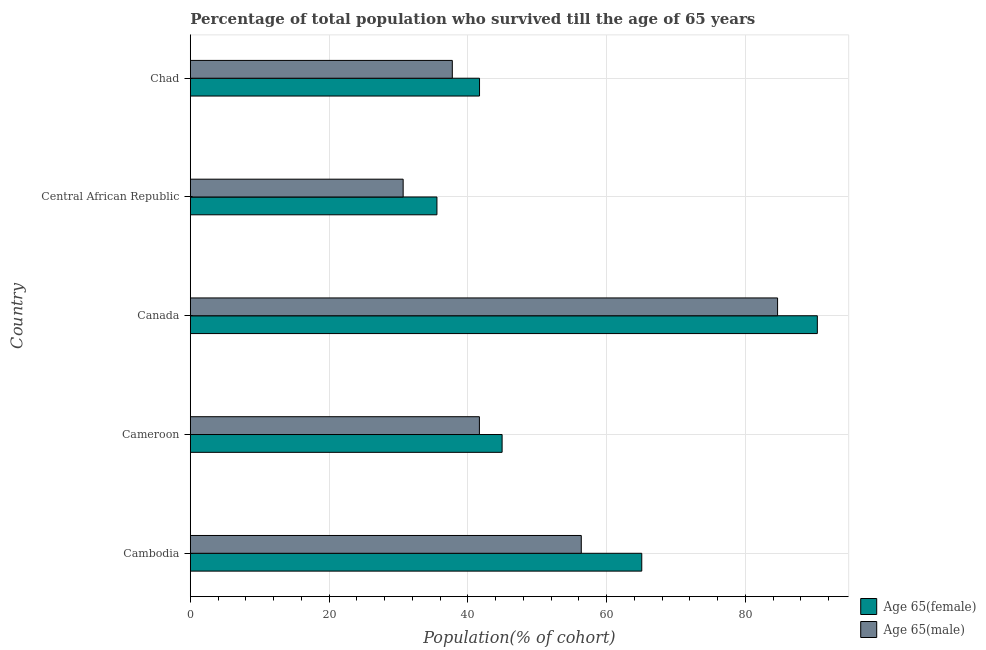How many groups of bars are there?
Offer a terse response. 5. Are the number of bars per tick equal to the number of legend labels?
Your answer should be compact. Yes. How many bars are there on the 3rd tick from the bottom?
Your answer should be very brief. 2. What is the label of the 5th group of bars from the top?
Provide a succinct answer. Cambodia. What is the percentage of female population who survived till age of 65 in Central African Republic?
Offer a terse response. 35.54. Across all countries, what is the maximum percentage of male population who survived till age of 65?
Provide a succinct answer. 84.63. Across all countries, what is the minimum percentage of female population who survived till age of 65?
Give a very brief answer. 35.54. In which country was the percentage of female population who survived till age of 65 minimum?
Give a very brief answer. Central African Republic. What is the total percentage of male population who survived till age of 65 in the graph?
Offer a terse response. 251.06. What is the difference between the percentage of female population who survived till age of 65 in Cameroon and that in Central African Republic?
Offer a very short reply. 9.39. What is the difference between the percentage of male population who survived till age of 65 in Central African Republic and the percentage of female population who survived till age of 65 in Cambodia?
Offer a very short reply. -34.38. What is the average percentage of female population who survived till age of 65 per country?
Ensure brevity in your answer.  55.51. What is the difference between the percentage of female population who survived till age of 65 and percentage of male population who survived till age of 65 in Chad?
Offer a very short reply. 3.92. What is the ratio of the percentage of female population who survived till age of 65 in Canada to that in Chad?
Offer a terse response. 2.17. Is the percentage of male population who survived till age of 65 in Cambodia less than that in Canada?
Your answer should be compact. Yes. What is the difference between the highest and the second highest percentage of female population who survived till age of 65?
Keep it short and to the point. 25.3. What is the difference between the highest and the lowest percentage of male population who survived till age of 65?
Give a very brief answer. 53.95. Is the sum of the percentage of male population who survived till age of 65 in Cambodia and Central African Republic greater than the maximum percentage of female population who survived till age of 65 across all countries?
Ensure brevity in your answer.  No. What does the 1st bar from the top in Cambodia represents?
Give a very brief answer. Age 65(male). What does the 1st bar from the bottom in Chad represents?
Keep it short and to the point. Age 65(female). How many bars are there?
Provide a succinct answer. 10. Are the values on the major ticks of X-axis written in scientific E-notation?
Your answer should be very brief. No. Does the graph contain any zero values?
Offer a very short reply. No. Where does the legend appear in the graph?
Give a very brief answer. Bottom right. What is the title of the graph?
Your answer should be compact. Percentage of total population who survived till the age of 65 years. Does "Old" appear as one of the legend labels in the graph?
Keep it short and to the point. No. What is the label or title of the X-axis?
Offer a very short reply. Population(% of cohort). What is the label or title of the Y-axis?
Give a very brief answer. Country. What is the Population(% of cohort) of Age 65(female) in Cambodia?
Offer a very short reply. 65.06. What is the Population(% of cohort) of Age 65(male) in Cambodia?
Your response must be concise. 56.34. What is the Population(% of cohort) in Age 65(female) in Cameroon?
Offer a very short reply. 44.93. What is the Population(% of cohort) in Age 65(male) in Cameroon?
Keep it short and to the point. 41.66. What is the Population(% of cohort) of Age 65(female) in Canada?
Provide a succinct answer. 90.36. What is the Population(% of cohort) in Age 65(male) in Canada?
Your answer should be very brief. 84.63. What is the Population(% of cohort) in Age 65(female) in Central African Republic?
Provide a succinct answer. 35.54. What is the Population(% of cohort) of Age 65(male) in Central African Republic?
Your answer should be compact. 30.67. What is the Population(% of cohort) of Age 65(female) in Chad?
Offer a very short reply. 41.68. What is the Population(% of cohort) of Age 65(male) in Chad?
Make the answer very short. 37.76. Across all countries, what is the maximum Population(% of cohort) of Age 65(female)?
Your answer should be very brief. 90.36. Across all countries, what is the maximum Population(% of cohort) in Age 65(male)?
Offer a very short reply. 84.63. Across all countries, what is the minimum Population(% of cohort) of Age 65(female)?
Offer a very short reply. 35.54. Across all countries, what is the minimum Population(% of cohort) in Age 65(male)?
Provide a short and direct response. 30.67. What is the total Population(% of cohort) in Age 65(female) in the graph?
Your answer should be very brief. 277.57. What is the total Population(% of cohort) in Age 65(male) in the graph?
Ensure brevity in your answer.  251.06. What is the difference between the Population(% of cohort) of Age 65(female) in Cambodia and that in Cameroon?
Ensure brevity in your answer.  20.12. What is the difference between the Population(% of cohort) of Age 65(male) in Cambodia and that in Cameroon?
Give a very brief answer. 14.68. What is the difference between the Population(% of cohort) in Age 65(female) in Cambodia and that in Canada?
Provide a short and direct response. -25.3. What is the difference between the Population(% of cohort) of Age 65(male) in Cambodia and that in Canada?
Offer a very short reply. -28.29. What is the difference between the Population(% of cohort) in Age 65(female) in Cambodia and that in Central African Republic?
Make the answer very short. 29.51. What is the difference between the Population(% of cohort) in Age 65(male) in Cambodia and that in Central African Republic?
Give a very brief answer. 25.67. What is the difference between the Population(% of cohort) in Age 65(female) in Cambodia and that in Chad?
Offer a very short reply. 23.38. What is the difference between the Population(% of cohort) in Age 65(male) in Cambodia and that in Chad?
Offer a terse response. 18.58. What is the difference between the Population(% of cohort) in Age 65(female) in Cameroon and that in Canada?
Give a very brief answer. -45.42. What is the difference between the Population(% of cohort) of Age 65(male) in Cameroon and that in Canada?
Your response must be concise. -42.97. What is the difference between the Population(% of cohort) of Age 65(female) in Cameroon and that in Central African Republic?
Keep it short and to the point. 9.39. What is the difference between the Population(% of cohort) of Age 65(male) in Cameroon and that in Central African Republic?
Provide a short and direct response. 10.99. What is the difference between the Population(% of cohort) in Age 65(female) in Cameroon and that in Chad?
Provide a succinct answer. 3.26. What is the difference between the Population(% of cohort) of Age 65(male) in Cameroon and that in Chad?
Offer a very short reply. 3.9. What is the difference between the Population(% of cohort) of Age 65(female) in Canada and that in Central African Republic?
Give a very brief answer. 54.82. What is the difference between the Population(% of cohort) of Age 65(male) in Canada and that in Central African Republic?
Provide a short and direct response. 53.95. What is the difference between the Population(% of cohort) of Age 65(female) in Canada and that in Chad?
Make the answer very short. 48.68. What is the difference between the Population(% of cohort) in Age 65(male) in Canada and that in Chad?
Your response must be concise. 46.87. What is the difference between the Population(% of cohort) of Age 65(female) in Central African Republic and that in Chad?
Your answer should be very brief. -6.14. What is the difference between the Population(% of cohort) in Age 65(male) in Central African Republic and that in Chad?
Make the answer very short. -7.08. What is the difference between the Population(% of cohort) in Age 65(female) in Cambodia and the Population(% of cohort) in Age 65(male) in Cameroon?
Offer a very short reply. 23.4. What is the difference between the Population(% of cohort) of Age 65(female) in Cambodia and the Population(% of cohort) of Age 65(male) in Canada?
Your answer should be very brief. -19.57. What is the difference between the Population(% of cohort) in Age 65(female) in Cambodia and the Population(% of cohort) in Age 65(male) in Central African Republic?
Make the answer very short. 34.38. What is the difference between the Population(% of cohort) in Age 65(female) in Cambodia and the Population(% of cohort) in Age 65(male) in Chad?
Make the answer very short. 27.3. What is the difference between the Population(% of cohort) in Age 65(female) in Cameroon and the Population(% of cohort) in Age 65(male) in Canada?
Your response must be concise. -39.69. What is the difference between the Population(% of cohort) of Age 65(female) in Cameroon and the Population(% of cohort) of Age 65(male) in Central African Republic?
Your answer should be very brief. 14.26. What is the difference between the Population(% of cohort) in Age 65(female) in Cameroon and the Population(% of cohort) in Age 65(male) in Chad?
Your answer should be very brief. 7.18. What is the difference between the Population(% of cohort) in Age 65(female) in Canada and the Population(% of cohort) in Age 65(male) in Central African Republic?
Offer a very short reply. 59.68. What is the difference between the Population(% of cohort) of Age 65(female) in Canada and the Population(% of cohort) of Age 65(male) in Chad?
Offer a very short reply. 52.6. What is the difference between the Population(% of cohort) in Age 65(female) in Central African Republic and the Population(% of cohort) in Age 65(male) in Chad?
Give a very brief answer. -2.22. What is the average Population(% of cohort) in Age 65(female) per country?
Ensure brevity in your answer.  55.51. What is the average Population(% of cohort) in Age 65(male) per country?
Ensure brevity in your answer.  50.21. What is the difference between the Population(% of cohort) in Age 65(female) and Population(% of cohort) in Age 65(male) in Cambodia?
Make the answer very short. 8.72. What is the difference between the Population(% of cohort) of Age 65(female) and Population(% of cohort) of Age 65(male) in Cameroon?
Offer a very short reply. 3.27. What is the difference between the Population(% of cohort) of Age 65(female) and Population(% of cohort) of Age 65(male) in Canada?
Give a very brief answer. 5.73. What is the difference between the Population(% of cohort) in Age 65(female) and Population(% of cohort) in Age 65(male) in Central African Republic?
Give a very brief answer. 4.87. What is the difference between the Population(% of cohort) in Age 65(female) and Population(% of cohort) in Age 65(male) in Chad?
Provide a short and direct response. 3.92. What is the ratio of the Population(% of cohort) in Age 65(female) in Cambodia to that in Cameroon?
Ensure brevity in your answer.  1.45. What is the ratio of the Population(% of cohort) in Age 65(male) in Cambodia to that in Cameroon?
Your response must be concise. 1.35. What is the ratio of the Population(% of cohort) in Age 65(female) in Cambodia to that in Canada?
Offer a very short reply. 0.72. What is the ratio of the Population(% of cohort) in Age 65(male) in Cambodia to that in Canada?
Keep it short and to the point. 0.67. What is the ratio of the Population(% of cohort) of Age 65(female) in Cambodia to that in Central African Republic?
Provide a succinct answer. 1.83. What is the ratio of the Population(% of cohort) in Age 65(male) in Cambodia to that in Central African Republic?
Your answer should be compact. 1.84. What is the ratio of the Population(% of cohort) of Age 65(female) in Cambodia to that in Chad?
Keep it short and to the point. 1.56. What is the ratio of the Population(% of cohort) of Age 65(male) in Cambodia to that in Chad?
Keep it short and to the point. 1.49. What is the ratio of the Population(% of cohort) of Age 65(female) in Cameroon to that in Canada?
Ensure brevity in your answer.  0.5. What is the ratio of the Population(% of cohort) of Age 65(male) in Cameroon to that in Canada?
Provide a short and direct response. 0.49. What is the ratio of the Population(% of cohort) of Age 65(female) in Cameroon to that in Central African Republic?
Offer a very short reply. 1.26. What is the ratio of the Population(% of cohort) in Age 65(male) in Cameroon to that in Central African Republic?
Offer a terse response. 1.36. What is the ratio of the Population(% of cohort) of Age 65(female) in Cameroon to that in Chad?
Give a very brief answer. 1.08. What is the ratio of the Population(% of cohort) of Age 65(male) in Cameroon to that in Chad?
Offer a terse response. 1.1. What is the ratio of the Population(% of cohort) of Age 65(female) in Canada to that in Central African Republic?
Make the answer very short. 2.54. What is the ratio of the Population(% of cohort) in Age 65(male) in Canada to that in Central African Republic?
Your answer should be compact. 2.76. What is the ratio of the Population(% of cohort) of Age 65(female) in Canada to that in Chad?
Make the answer very short. 2.17. What is the ratio of the Population(% of cohort) in Age 65(male) in Canada to that in Chad?
Provide a succinct answer. 2.24. What is the ratio of the Population(% of cohort) of Age 65(female) in Central African Republic to that in Chad?
Keep it short and to the point. 0.85. What is the ratio of the Population(% of cohort) of Age 65(male) in Central African Republic to that in Chad?
Your answer should be very brief. 0.81. What is the difference between the highest and the second highest Population(% of cohort) in Age 65(female)?
Keep it short and to the point. 25.3. What is the difference between the highest and the second highest Population(% of cohort) of Age 65(male)?
Offer a terse response. 28.29. What is the difference between the highest and the lowest Population(% of cohort) in Age 65(female)?
Provide a succinct answer. 54.82. What is the difference between the highest and the lowest Population(% of cohort) of Age 65(male)?
Ensure brevity in your answer.  53.95. 